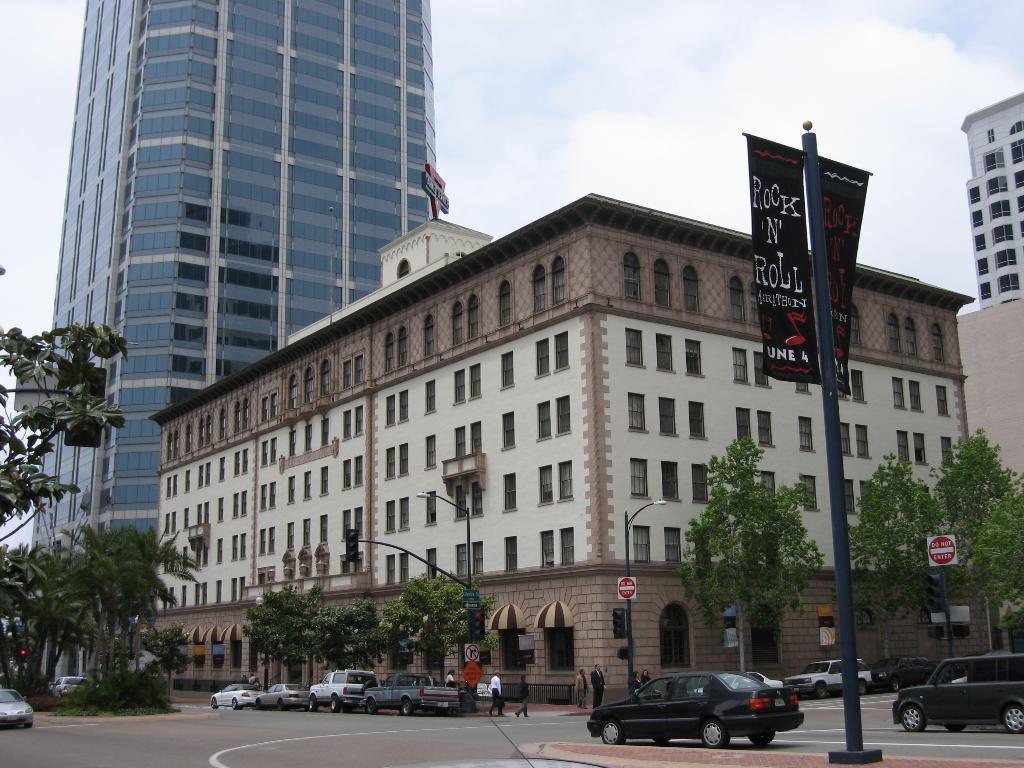In one or two sentences, can you explain what this image depicts? These are the buildings with the windows and glass doors. I can see the trees. These are the cars on the road. This looks like a banner, which is attached to a pole. I can see the street lights. This looks like a traffic signal, which is attached to a pole. There are groups of people standing. This is the sky. I think this is a name board, which is at the top of a building. 